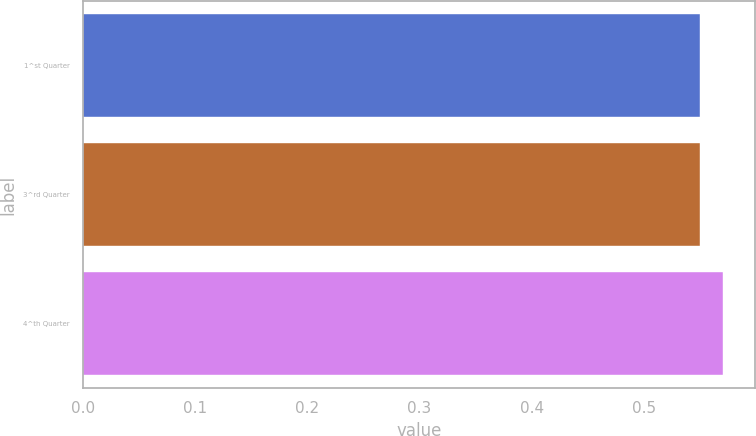Convert chart. <chart><loc_0><loc_0><loc_500><loc_500><bar_chart><fcel>1^st Quarter<fcel>3^rd Quarter<fcel>4^th Quarter<nl><fcel>0.55<fcel>0.55<fcel>0.57<nl></chart> 